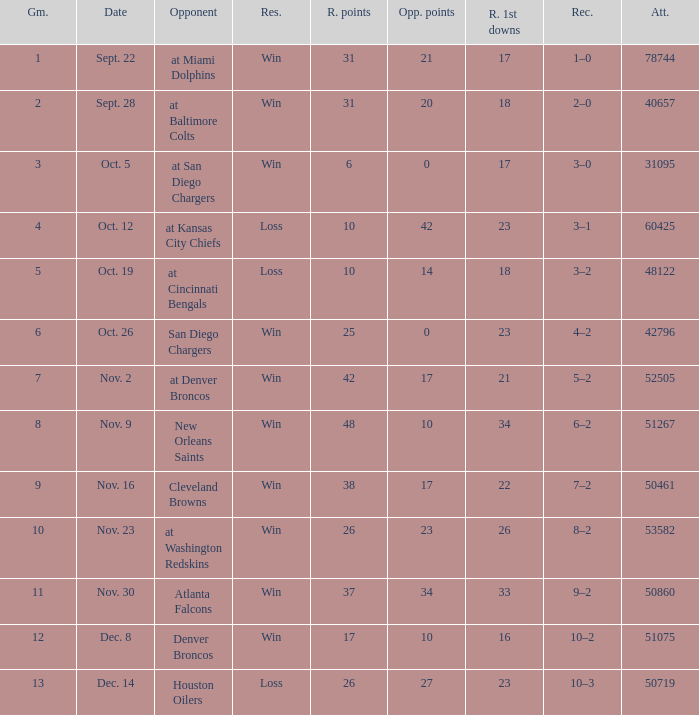Who was the game attended by 60425 people played against? At kansas city chiefs. 